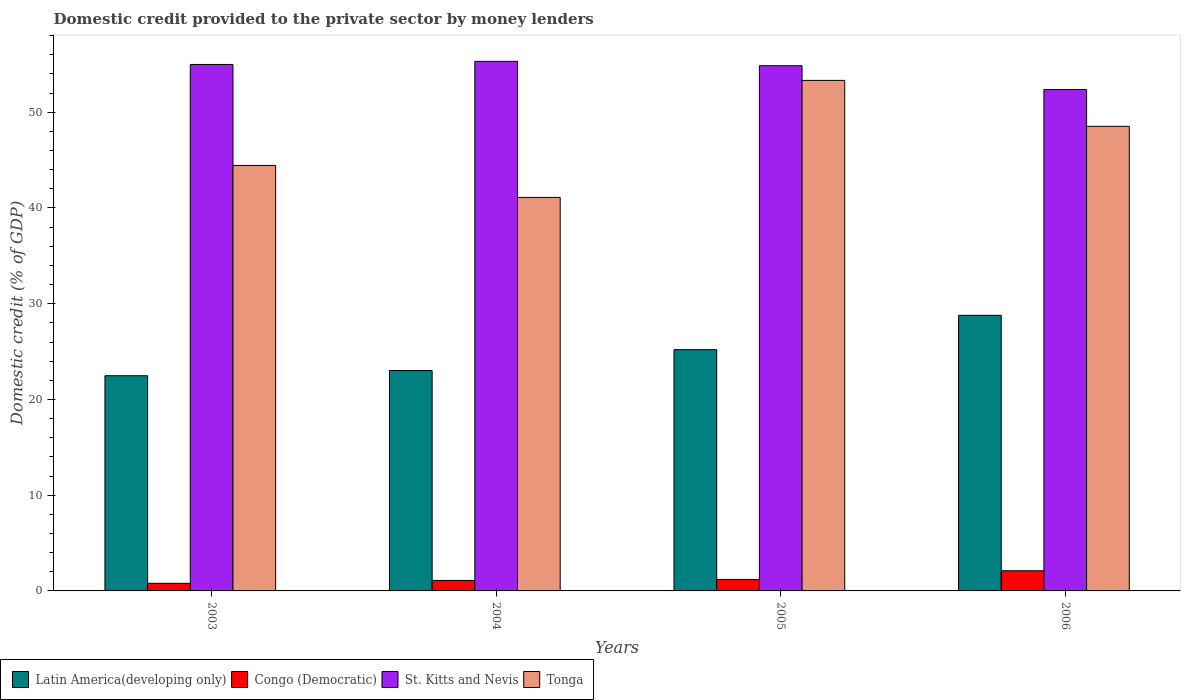How many different coloured bars are there?
Provide a succinct answer. 4. How many groups of bars are there?
Keep it short and to the point. 4. Are the number of bars per tick equal to the number of legend labels?
Ensure brevity in your answer.  Yes. How many bars are there on the 2nd tick from the right?
Your answer should be very brief. 4. In how many cases, is the number of bars for a given year not equal to the number of legend labels?
Provide a short and direct response. 0. What is the domestic credit provided to the private sector by money lenders in Congo (Democratic) in 2003?
Make the answer very short. 0.8. Across all years, what is the maximum domestic credit provided to the private sector by money lenders in Congo (Democratic)?
Keep it short and to the point. 2.11. Across all years, what is the minimum domestic credit provided to the private sector by money lenders in Congo (Democratic)?
Your answer should be compact. 0.8. In which year was the domestic credit provided to the private sector by money lenders in Tonga maximum?
Give a very brief answer. 2005. In which year was the domestic credit provided to the private sector by money lenders in Latin America(developing only) minimum?
Offer a very short reply. 2003. What is the total domestic credit provided to the private sector by money lenders in St. Kitts and Nevis in the graph?
Your answer should be compact. 217.55. What is the difference between the domestic credit provided to the private sector by money lenders in Congo (Democratic) in 2003 and that in 2006?
Ensure brevity in your answer.  -1.31. What is the difference between the domestic credit provided to the private sector by money lenders in Latin America(developing only) in 2003 and the domestic credit provided to the private sector by money lenders in Congo (Democratic) in 2006?
Make the answer very short. 20.37. What is the average domestic credit provided to the private sector by money lenders in St. Kitts and Nevis per year?
Give a very brief answer. 54.39. In the year 2006, what is the difference between the domestic credit provided to the private sector by money lenders in Tonga and domestic credit provided to the private sector by money lenders in St. Kitts and Nevis?
Give a very brief answer. -3.85. What is the ratio of the domestic credit provided to the private sector by money lenders in Congo (Democratic) in 2005 to that in 2006?
Make the answer very short. 0.57. Is the difference between the domestic credit provided to the private sector by money lenders in Tonga in 2005 and 2006 greater than the difference between the domestic credit provided to the private sector by money lenders in St. Kitts and Nevis in 2005 and 2006?
Give a very brief answer. Yes. What is the difference between the highest and the second highest domestic credit provided to the private sector by money lenders in Latin America(developing only)?
Give a very brief answer. 3.59. What is the difference between the highest and the lowest domestic credit provided to the private sector by money lenders in St. Kitts and Nevis?
Offer a very short reply. 2.94. Is the sum of the domestic credit provided to the private sector by money lenders in Congo (Democratic) in 2003 and 2005 greater than the maximum domestic credit provided to the private sector by money lenders in St. Kitts and Nevis across all years?
Provide a short and direct response. No. Is it the case that in every year, the sum of the domestic credit provided to the private sector by money lenders in St. Kitts and Nevis and domestic credit provided to the private sector by money lenders in Tonga is greater than the sum of domestic credit provided to the private sector by money lenders in Congo (Democratic) and domestic credit provided to the private sector by money lenders in Latin America(developing only)?
Offer a terse response. No. What does the 3rd bar from the left in 2005 represents?
Your answer should be very brief. St. Kitts and Nevis. What does the 1st bar from the right in 2006 represents?
Your answer should be very brief. Tonga. Is it the case that in every year, the sum of the domestic credit provided to the private sector by money lenders in St. Kitts and Nevis and domestic credit provided to the private sector by money lenders in Latin America(developing only) is greater than the domestic credit provided to the private sector by money lenders in Tonga?
Offer a terse response. Yes. How many years are there in the graph?
Offer a terse response. 4. Does the graph contain grids?
Offer a terse response. No. Where does the legend appear in the graph?
Ensure brevity in your answer.  Bottom left. How are the legend labels stacked?
Provide a succinct answer. Horizontal. What is the title of the graph?
Your response must be concise. Domestic credit provided to the private sector by money lenders. Does "Colombia" appear as one of the legend labels in the graph?
Ensure brevity in your answer.  No. What is the label or title of the Y-axis?
Ensure brevity in your answer.  Domestic credit (% of GDP). What is the Domestic credit (% of GDP) in Latin America(developing only) in 2003?
Offer a very short reply. 22.48. What is the Domestic credit (% of GDP) of Congo (Democratic) in 2003?
Ensure brevity in your answer.  0.8. What is the Domestic credit (% of GDP) in St. Kitts and Nevis in 2003?
Provide a short and direct response. 54.99. What is the Domestic credit (% of GDP) in Tonga in 2003?
Your answer should be very brief. 44.44. What is the Domestic credit (% of GDP) in Latin America(developing only) in 2004?
Offer a very short reply. 23.02. What is the Domestic credit (% of GDP) of Congo (Democratic) in 2004?
Offer a terse response. 1.1. What is the Domestic credit (% of GDP) in St. Kitts and Nevis in 2004?
Provide a short and direct response. 55.32. What is the Domestic credit (% of GDP) of Tonga in 2004?
Your response must be concise. 41.11. What is the Domestic credit (% of GDP) in Latin America(developing only) in 2005?
Give a very brief answer. 25.2. What is the Domestic credit (% of GDP) of Congo (Democratic) in 2005?
Ensure brevity in your answer.  1.2. What is the Domestic credit (% of GDP) of St. Kitts and Nevis in 2005?
Offer a terse response. 54.86. What is the Domestic credit (% of GDP) of Tonga in 2005?
Your answer should be very brief. 53.33. What is the Domestic credit (% of GDP) in Latin America(developing only) in 2006?
Your answer should be very brief. 28.79. What is the Domestic credit (% of GDP) of Congo (Democratic) in 2006?
Your response must be concise. 2.11. What is the Domestic credit (% of GDP) of St. Kitts and Nevis in 2006?
Offer a terse response. 52.38. What is the Domestic credit (% of GDP) of Tonga in 2006?
Your answer should be compact. 48.53. Across all years, what is the maximum Domestic credit (% of GDP) of Latin America(developing only)?
Offer a terse response. 28.79. Across all years, what is the maximum Domestic credit (% of GDP) of Congo (Democratic)?
Make the answer very short. 2.11. Across all years, what is the maximum Domestic credit (% of GDP) in St. Kitts and Nevis?
Make the answer very short. 55.32. Across all years, what is the maximum Domestic credit (% of GDP) in Tonga?
Offer a very short reply. 53.33. Across all years, what is the minimum Domestic credit (% of GDP) of Latin America(developing only)?
Your answer should be compact. 22.48. Across all years, what is the minimum Domestic credit (% of GDP) in Congo (Democratic)?
Give a very brief answer. 0.8. Across all years, what is the minimum Domestic credit (% of GDP) in St. Kitts and Nevis?
Keep it short and to the point. 52.38. Across all years, what is the minimum Domestic credit (% of GDP) of Tonga?
Your answer should be very brief. 41.11. What is the total Domestic credit (% of GDP) of Latin America(developing only) in the graph?
Provide a short and direct response. 99.49. What is the total Domestic credit (% of GDP) of Congo (Democratic) in the graph?
Provide a short and direct response. 5.2. What is the total Domestic credit (% of GDP) in St. Kitts and Nevis in the graph?
Keep it short and to the point. 217.55. What is the total Domestic credit (% of GDP) in Tonga in the graph?
Ensure brevity in your answer.  187.41. What is the difference between the Domestic credit (% of GDP) in Latin America(developing only) in 2003 and that in 2004?
Your answer should be very brief. -0.54. What is the difference between the Domestic credit (% of GDP) of Congo (Democratic) in 2003 and that in 2004?
Provide a succinct answer. -0.3. What is the difference between the Domestic credit (% of GDP) in St. Kitts and Nevis in 2003 and that in 2004?
Provide a short and direct response. -0.33. What is the difference between the Domestic credit (% of GDP) in Tonga in 2003 and that in 2004?
Ensure brevity in your answer.  3.34. What is the difference between the Domestic credit (% of GDP) in Latin America(developing only) in 2003 and that in 2005?
Make the answer very short. -2.72. What is the difference between the Domestic credit (% of GDP) in Congo (Democratic) in 2003 and that in 2005?
Your answer should be compact. -0.41. What is the difference between the Domestic credit (% of GDP) of St. Kitts and Nevis in 2003 and that in 2005?
Ensure brevity in your answer.  0.13. What is the difference between the Domestic credit (% of GDP) in Tonga in 2003 and that in 2005?
Your answer should be very brief. -8.88. What is the difference between the Domestic credit (% of GDP) of Latin America(developing only) in 2003 and that in 2006?
Provide a short and direct response. -6.31. What is the difference between the Domestic credit (% of GDP) in Congo (Democratic) in 2003 and that in 2006?
Offer a terse response. -1.31. What is the difference between the Domestic credit (% of GDP) of St. Kitts and Nevis in 2003 and that in 2006?
Provide a short and direct response. 2.62. What is the difference between the Domestic credit (% of GDP) of Tonga in 2003 and that in 2006?
Provide a succinct answer. -4.09. What is the difference between the Domestic credit (% of GDP) in Latin America(developing only) in 2004 and that in 2005?
Ensure brevity in your answer.  -2.18. What is the difference between the Domestic credit (% of GDP) of Congo (Democratic) in 2004 and that in 2005?
Offer a terse response. -0.11. What is the difference between the Domestic credit (% of GDP) in St. Kitts and Nevis in 2004 and that in 2005?
Make the answer very short. 0.45. What is the difference between the Domestic credit (% of GDP) in Tonga in 2004 and that in 2005?
Provide a short and direct response. -12.22. What is the difference between the Domestic credit (% of GDP) in Latin America(developing only) in 2004 and that in 2006?
Make the answer very short. -5.76. What is the difference between the Domestic credit (% of GDP) in Congo (Democratic) in 2004 and that in 2006?
Offer a terse response. -1.01. What is the difference between the Domestic credit (% of GDP) of St. Kitts and Nevis in 2004 and that in 2006?
Your answer should be very brief. 2.94. What is the difference between the Domestic credit (% of GDP) of Tonga in 2004 and that in 2006?
Keep it short and to the point. -7.42. What is the difference between the Domestic credit (% of GDP) in Latin America(developing only) in 2005 and that in 2006?
Your answer should be very brief. -3.59. What is the difference between the Domestic credit (% of GDP) in Congo (Democratic) in 2005 and that in 2006?
Provide a short and direct response. -0.9. What is the difference between the Domestic credit (% of GDP) in St. Kitts and Nevis in 2005 and that in 2006?
Your answer should be compact. 2.49. What is the difference between the Domestic credit (% of GDP) of Tonga in 2005 and that in 2006?
Give a very brief answer. 4.8. What is the difference between the Domestic credit (% of GDP) in Latin America(developing only) in 2003 and the Domestic credit (% of GDP) in Congo (Democratic) in 2004?
Ensure brevity in your answer.  21.38. What is the difference between the Domestic credit (% of GDP) in Latin America(developing only) in 2003 and the Domestic credit (% of GDP) in St. Kitts and Nevis in 2004?
Give a very brief answer. -32.84. What is the difference between the Domestic credit (% of GDP) of Latin America(developing only) in 2003 and the Domestic credit (% of GDP) of Tonga in 2004?
Make the answer very short. -18.63. What is the difference between the Domestic credit (% of GDP) of Congo (Democratic) in 2003 and the Domestic credit (% of GDP) of St. Kitts and Nevis in 2004?
Keep it short and to the point. -54.52. What is the difference between the Domestic credit (% of GDP) in Congo (Democratic) in 2003 and the Domestic credit (% of GDP) in Tonga in 2004?
Provide a succinct answer. -40.31. What is the difference between the Domestic credit (% of GDP) of St. Kitts and Nevis in 2003 and the Domestic credit (% of GDP) of Tonga in 2004?
Provide a succinct answer. 13.89. What is the difference between the Domestic credit (% of GDP) in Latin America(developing only) in 2003 and the Domestic credit (% of GDP) in Congo (Democratic) in 2005?
Offer a terse response. 21.28. What is the difference between the Domestic credit (% of GDP) in Latin America(developing only) in 2003 and the Domestic credit (% of GDP) in St. Kitts and Nevis in 2005?
Your answer should be compact. -32.38. What is the difference between the Domestic credit (% of GDP) of Latin America(developing only) in 2003 and the Domestic credit (% of GDP) of Tonga in 2005?
Provide a short and direct response. -30.85. What is the difference between the Domestic credit (% of GDP) in Congo (Democratic) in 2003 and the Domestic credit (% of GDP) in St. Kitts and Nevis in 2005?
Keep it short and to the point. -54.07. What is the difference between the Domestic credit (% of GDP) of Congo (Democratic) in 2003 and the Domestic credit (% of GDP) of Tonga in 2005?
Ensure brevity in your answer.  -52.53. What is the difference between the Domestic credit (% of GDP) in St. Kitts and Nevis in 2003 and the Domestic credit (% of GDP) in Tonga in 2005?
Your answer should be very brief. 1.66. What is the difference between the Domestic credit (% of GDP) in Latin America(developing only) in 2003 and the Domestic credit (% of GDP) in Congo (Democratic) in 2006?
Offer a very short reply. 20.37. What is the difference between the Domestic credit (% of GDP) of Latin America(developing only) in 2003 and the Domestic credit (% of GDP) of St. Kitts and Nevis in 2006?
Provide a short and direct response. -29.9. What is the difference between the Domestic credit (% of GDP) in Latin America(developing only) in 2003 and the Domestic credit (% of GDP) in Tonga in 2006?
Your response must be concise. -26.05. What is the difference between the Domestic credit (% of GDP) in Congo (Democratic) in 2003 and the Domestic credit (% of GDP) in St. Kitts and Nevis in 2006?
Your response must be concise. -51.58. What is the difference between the Domestic credit (% of GDP) of Congo (Democratic) in 2003 and the Domestic credit (% of GDP) of Tonga in 2006?
Provide a succinct answer. -47.73. What is the difference between the Domestic credit (% of GDP) in St. Kitts and Nevis in 2003 and the Domestic credit (% of GDP) in Tonga in 2006?
Make the answer very short. 6.46. What is the difference between the Domestic credit (% of GDP) in Latin America(developing only) in 2004 and the Domestic credit (% of GDP) in Congo (Democratic) in 2005?
Your response must be concise. 21.82. What is the difference between the Domestic credit (% of GDP) in Latin America(developing only) in 2004 and the Domestic credit (% of GDP) in St. Kitts and Nevis in 2005?
Keep it short and to the point. -31.84. What is the difference between the Domestic credit (% of GDP) in Latin America(developing only) in 2004 and the Domestic credit (% of GDP) in Tonga in 2005?
Provide a succinct answer. -30.31. What is the difference between the Domestic credit (% of GDP) of Congo (Democratic) in 2004 and the Domestic credit (% of GDP) of St. Kitts and Nevis in 2005?
Make the answer very short. -53.77. What is the difference between the Domestic credit (% of GDP) of Congo (Democratic) in 2004 and the Domestic credit (% of GDP) of Tonga in 2005?
Your answer should be compact. -52.23. What is the difference between the Domestic credit (% of GDP) in St. Kitts and Nevis in 2004 and the Domestic credit (% of GDP) in Tonga in 2005?
Offer a terse response. 1.99. What is the difference between the Domestic credit (% of GDP) in Latin America(developing only) in 2004 and the Domestic credit (% of GDP) in Congo (Democratic) in 2006?
Give a very brief answer. 20.92. What is the difference between the Domestic credit (% of GDP) of Latin America(developing only) in 2004 and the Domestic credit (% of GDP) of St. Kitts and Nevis in 2006?
Keep it short and to the point. -29.35. What is the difference between the Domestic credit (% of GDP) in Latin America(developing only) in 2004 and the Domestic credit (% of GDP) in Tonga in 2006?
Make the answer very short. -25.51. What is the difference between the Domestic credit (% of GDP) of Congo (Democratic) in 2004 and the Domestic credit (% of GDP) of St. Kitts and Nevis in 2006?
Offer a very short reply. -51.28. What is the difference between the Domestic credit (% of GDP) of Congo (Democratic) in 2004 and the Domestic credit (% of GDP) of Tonga in 2006?
Offer a terse response. -47.44. What is the difference between the Domestic credit (% of GDP) in St. Kitts and Nevis in 2004 and the Domestic credit (% of GDP) in Tonga in 2006?
Offer a terse response. 6.79. What is the difference between the Domestic credit (% of GDP) in Latin America(developing only) in 2005 and the Domestic credit (% of GDP) in Congo (Democratic) in 2006?
Keep it short and to the point. 23.09. What is the difference between the Domestic credit (% of GDP) in Latin America(developing only) in 2005 and the Domestic credit (% of GDP) in St. Kitts and Nevis in 2006?
Your answer should be compact. -27.18. What is the difference between the Domestic credit (% of GDP) in Latin America(developing only) in 2005 and the Domestic credit (% of GDP) in Tonga in 2006?
Make the answer very short. -23.33. What is the difference between the Domestic credit (% of GDP) of Congo (Democratic) in 2005 and the Domestic credit (% of GDP) of St. Kitts and Nevis in 2006?
Provide a succinct answer. -51.18. What is the difference between the Domestic credit (% of GDP) of Congo (Democratic) in 2005 and the Domestic credit (% of GDP) of Tonga in 2006?
Your answer should be very brief. -47.33. What is the difference between the Domestic credit (% of GDP) in St. Kitts and Nevis in 2005 and the Domestic credit (% of GDP) in Tonga in 2006?
Offer a very short reply. 6.33. What is the average Domestic credit (% of GDP) in Latin America(developing only) per year?
Offer a terse response. 24.87. What is the average Domestic credit (% of GDP) in Congo (Democratic) per year?
Make the answer very short. 1.3. What is the average Domestic credit (% of GDP) of St. Kitts and Nevis per year?
Your answer should be very brief. 54.39. What is the average Domestic credit (% of GDP) of Tonga per year?
Make the answer very short. 46.85. In the year 2003, what is the difference between the Domestic credit (% of GDP) in Latin America(developing only) and Domestic credit (% of GDP) in Congo (Democratic)?
Ensure brevity in your answer.  21.68. In the year 2003, what is the difference between the Domestic credit (% of GDP) in Latin America(developing only) and Domestic credit (% of GDP) in St. Kitts and Nevis?
Ensure brevity in your answer.  -32.51. In the year 2003, what is the difference between the Domestic credit (% of GDP) of Latin America(developing only) and Domestic credit (% of GDP) of Tonga?
Keep it short and to the point. -21.96. In the year 2003, what is the difference between the Domestic credit (% of GDP) of Congo (Democratic) and Domestic credit (% of GDP) of St. Kitts and Nevis?
Make the answer very short. -54.2. In the year 2003, what is the difference between the Domestic credit (% of GDP) of Congo (Democratic) and Domestic credit (% of GDP) of Tonga?
Your answer should be very brief. -43.65. In the year 2003, what is the difference between the Domestic credit (% of GDP) of St. Kitts and Nevis and Domestic credit (% of GDP) of Tonga?
Your answer should be very brief. 10.55. In the year 2004, what is the difference between the Domestic credit (% of GDP) in Latin America(developing only) and Domestic credit (% of GDP) in Congo (Democratic)?
Provide a short and direct response. 21.93. In the year 2004, what is the difference between the Domestic credit (% of GDP) of Latin America(developing only) and Domestic credit (% of GDP) of St. Kitts and Nevis?
Your answer should be compact. -32.29. In the year 2004, what is the difference between the Domestic credit (% of GDP) in Latin America(developing only) and Domestic credit (% of GDP) in Tonga?
Keep it short and to the point. -18.08. In the year 2004, what is the difference between the Domestic credit (% of GDP) of Congo (Democratic) and Domestic credit (% of GDP) of St. Kitts and Nevis?
Offer a very short reply. -54.22. In the year 2004, what is the difference between the Domestic credit (% of GDP) of Congo (Democratic) and Domestic credit (% of GDP) of Tonga?
Offer a terse response. -40.01. In the year 2004, what is the difference between the Domestic credit (% of GDP) in St. Kitts and Nevis and Domestic credit (% of GDP) in Tonga?
Make the answer very short. 14.21. In the year 2005, what is the difference between the Domestic credit (% of GDP) of Latin America(developing only) and Domestic credit (% of GDP) of Congo (Democratic)?
Give a very brief answer. 24. In the year 2005, what is the difference between the Domestic credit (% of GDP) in Latin America(developing only) and Domestic credit (% of GDP) in St. Kitts and Nevis?
Keep it short and to the point. -29.66. In the year 2005, what is the difference between the Domestic credit (% of GDP) of Latin America(developing only) and Domestic credit (% of GDP) of Tonga?
Offer a very short reply. -28.13. In the year 2005, what is the difference between the Domestic credit (% of GDP) of Congo (Democratic) and Domestic credit (% of GDP) of St. Kitts and Nevis?
Make the answer very short. -53.66. In the year 2005, what is the difference between the Domestic credit (% of GDP) of Congo (Democratic) and Domestic credit (% of GDP) of Tonga?
Provide a succinct answer. -52.13. In the year 2005, what is the difference between the Domestic credit (% of GDP) in St. Kitts and Nevis and Domestic credit (% of GDP) in Tonga?
Provide a short and direct response. 1.53. In the year 2006, what is the difference between the Domestic credit (% of GDP) in Latin America(developing only) and Domestic credit (% of GDP) in Congo (Democratic)?
Keep it short and to the point. 26.68. In the year 2006, what is the difference between the Domestic credit (% of GDP) of Latin America(developing only) and Domestic credit (% of GDP) of St. Kitts and Nevis?
Keep it short and to the point. -23.59. In the year 2006, what is the difference between the Domestic credit (% of GDP) in Latin America(developing only) and Domestic credit (% of GDP) in Tonga?
Your answer should be very brief. -19.74. In the year 2006, what is the difference between the Domestic credit (% of GDP) in Congo (Democratic) and Domestic credit (% of GDP) in St. Kitts and Nevis?
Keep it short and to the point. -50.27. In the year 2006, what is the difference between the Domestic credit (% of GDP) in Congo (Democratic) and Domestic credit (% of GDP) in Tonga?
Provide a succinct answer. -46.43. In the year 2006, what is the difference between the Domestic credit (% of GDP) in St. Kitts and Nevis and Domestic credit (% of GDP) in Tonga?
Provide a succinct answer. 3.85. What is the ratio of the Domestic credit (% of GDP) of Latin America(developing only) in 2003 to that in 2004?
Your answer should be compact. 0.98. What is the ratio of the Domestic credit (% of GDP) in Congo (Democratic) in 2003 to that in 2004?
Your response must be concise. 0.73. What is the ratio of the Domestic credit (% of GDP) in Tonga in 2003 to that in 2004?
Keep it short and to the point. 1.08. What is the ratio of the Domestic credit (% of GDP) of Latin America(developing only) in 2003 to that in 2005?
Keep it short and to the point. 0.89. What is the ratio of the Domestic credit (% of GDP) of Congo (Democratic) in 2003 to that in 2005?
Your answer should be compact. 0.66. What is the ratio of the Domestic credit (% of GDP) in St. Kitts and Nevis in 2003 to that in 2005?
Provide a short and direct response. 1. What is the ratio of the Domestic credit (% of GDP) in Tonga in 2003 to that in 2005?
Ensure brevity in your answer.  0.83. What is the ratio of the Domestic credit (% of GDP) of Latin America(developing only) in 2003 to that in 2006?
Offer a terse response. 0.78. What is the ratio of the Domestic credit (% of GDP) of Congo (Democratic) in 2003 to that in 2006?
Give a very brief answer. 0.38. What is the ratio of the Domestic credit (% of GDP) in Tonga in 2003 to that in 2006?
Provide a succinct answer. 0.92. What is the ratio of the Domestic credit (% of GDP) of Latin America(developing only) in 2004 to that in 2005?
Ensure brevity in your answer.  0.91. What is the ratio of the Domestic credit (% of GDP) in Congo (Democratic) in 2004 to that in 2005?
Make the answer very short. 0.91. What is the ratio of the Domestic credit (% of GDP) of St. Kitts and Nevis in 2004 to that in 2005?
Offer a terse response. 1.01. What is the ratio of the Domestic credit (% of GDP) of Tonga in 2004 to that in 2005?
Your response must be concise. 0.77. What is the ratio of the Domestic credit (% of GDP) in Latin America(developing only) in 2004 to that in 2006?
Ensure brevity in your answer.  0.8. What is the ratio of the Domestic credit (% of GDP) of Congo (Democratic) in 2004 to that in 2006?
Your response must be concise. 0.52. What is the ratio of the Domestic credit (% of GDP) in St. Kitts and Nevis in 2004 to that in 2006?
Provide a short and direct response. 1.06. What is the ratio of the Domestic credit (% of GDP) of Tonga in 2004 to that in 2006?
Your answer should be compact. 0.85. What is the ratio of the Domestic credit (% of GDP) of Latin America(developing only) in 2005 to that in 2006?
Offer a terse response. 0.88. What is the ratio of the Domestic credit (% of GDP) of Congo (Democratic) in 2005 to that in 2006?
Offer a very short reply. 0.57. What is the ratio of the Domestic credit (% of GDP) in St. Kitts and Nevis in 2005 to that in 2006?
Your response must be concise. 1.05. What is the ratio of the Domestic credit (% of GDP) in Tonga in 2005 to that in 2006?
Provide a short and direct response. 1.1. What is the difference between the highest and the second highest Domestic credit (% of GDP) of Latin America(developing only)?
Give a very brief answer. 3.59. What is the difference between the highest and the second highest Domestic credit (% of GDP) of Congo (Democratic)?
Make the answer very short. 0.9. What is the difference between the highest and the second highest Domestic credit (% of GDP) in St. Kitts and Nevis?
Your answer should be very brief. 0.33. What is the difference between the highest and the second highest Domestic credit (% of GDP) of Tonga?
Your answer should be compact. 4.8. What is the difference between the highest and the lowest Domestic credit (% of GDP) in Latin America(developing only)?
Provide a succinct answer. 6.31. What is the difference between the highest and the lowest Domestic credit (% of GDP) in Congo (Democratic)?
Provide a succinct answer. 1.31. What is the difference between the highest and the lowest Domestic credit (% of GDP) of St. Kitts and Nevis?
Offer a very short reply. 2.94. What is the difference between the highest and the lowest Domestic credit (% of GDP) in Tonga?
Keep it short and to the point. 12.22. 